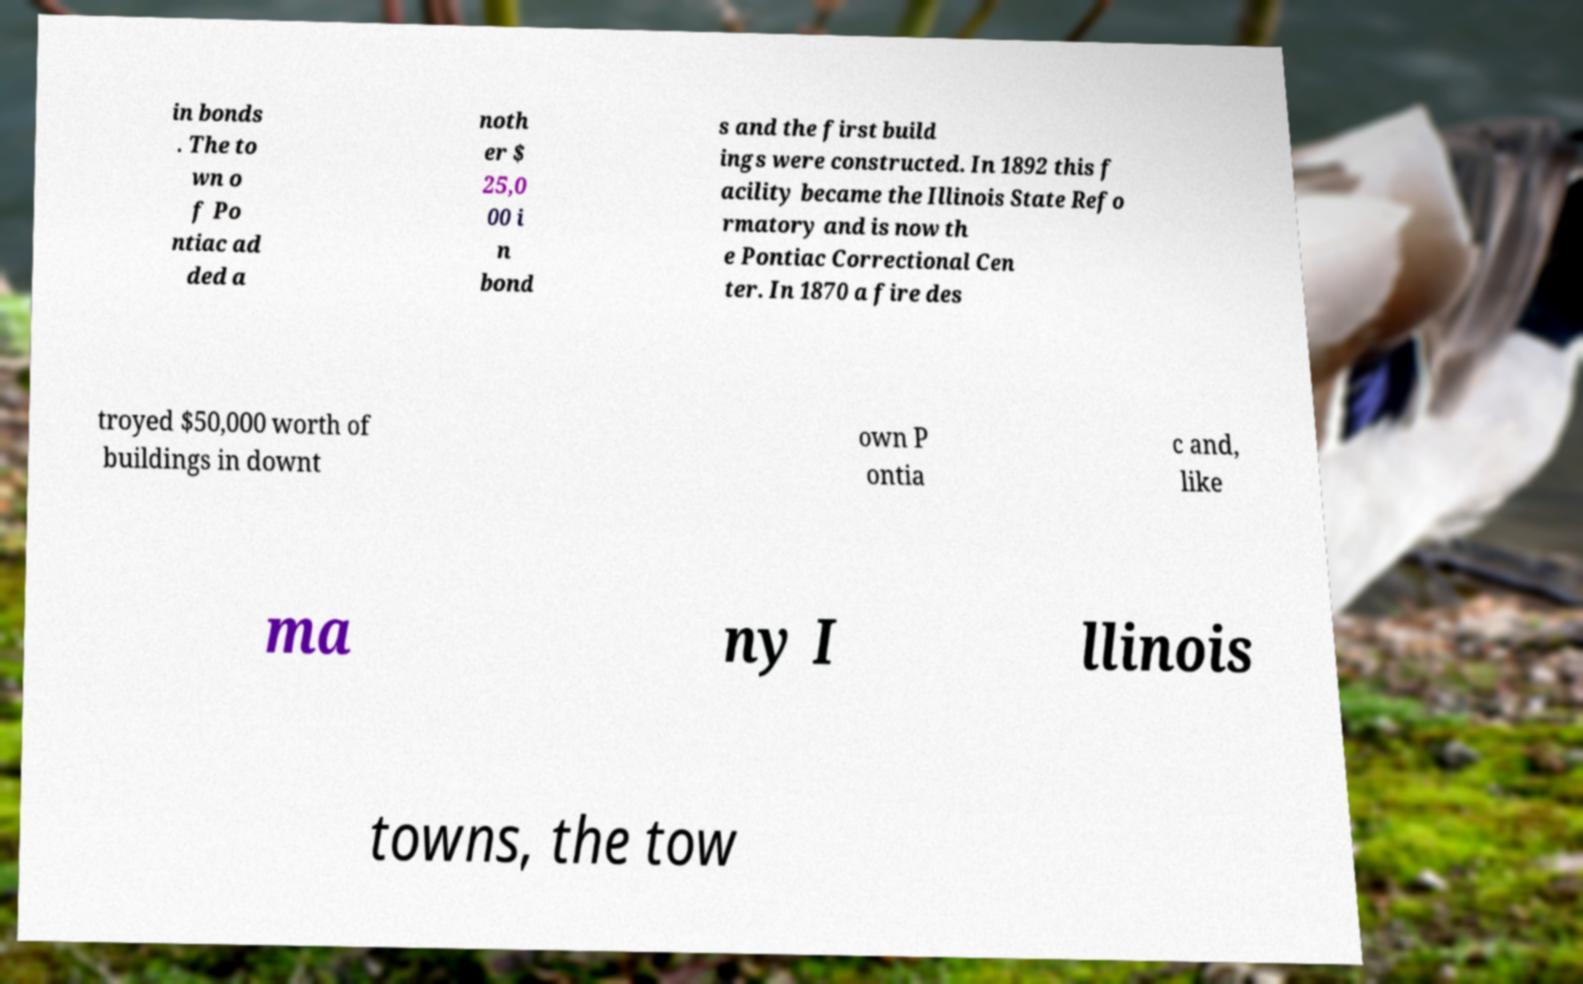There's text embedded in this image that I need extracted. Can you transcribe it verbatim? in bonds . The to wn o f Po ntiac ad ded a noth er $ 25,0 00 i n bond s and the first build ings were constructed. In 1892 this f acility became the Illinois State Refo rmatory and is now th e Pontiac Correctional Cen ter. In 1870 a fire des troyed $50,000 worth of buildings in downt own P ontia c and, like ma ny I llinois towns, the tow 